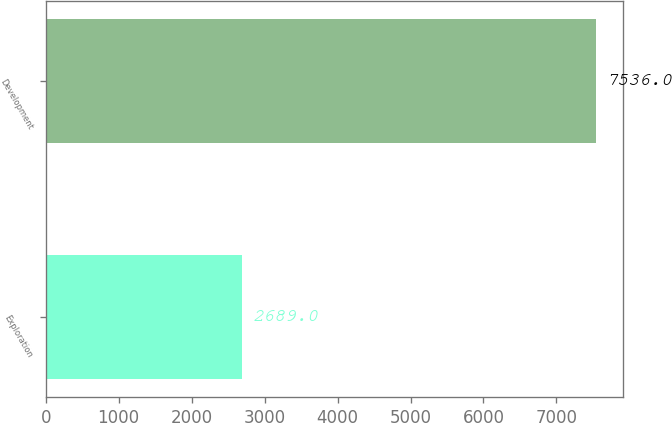<chart> <loc_0><loc_0><loc_500><loc_500><bar_chart><fcel>Exploration<fcel>Development<nl><fcel>2689<fcel>7536<nl></chart> 